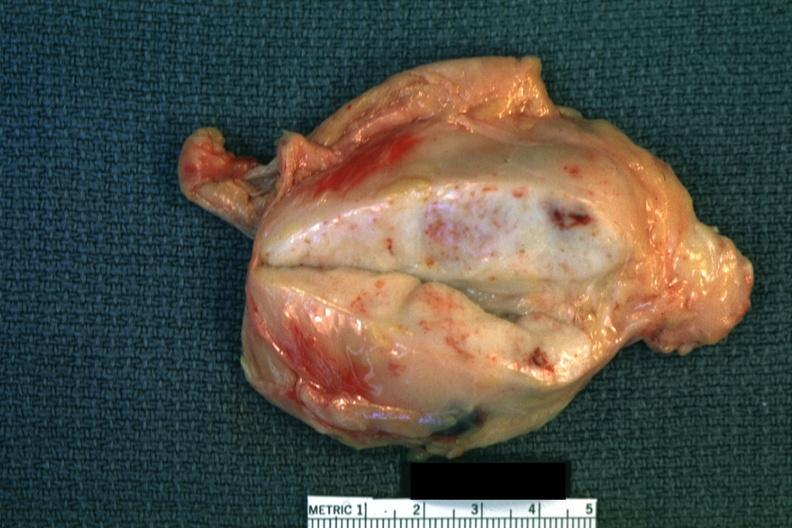s gangrene fingers present?
Answer the question using a single word or phrase. No 